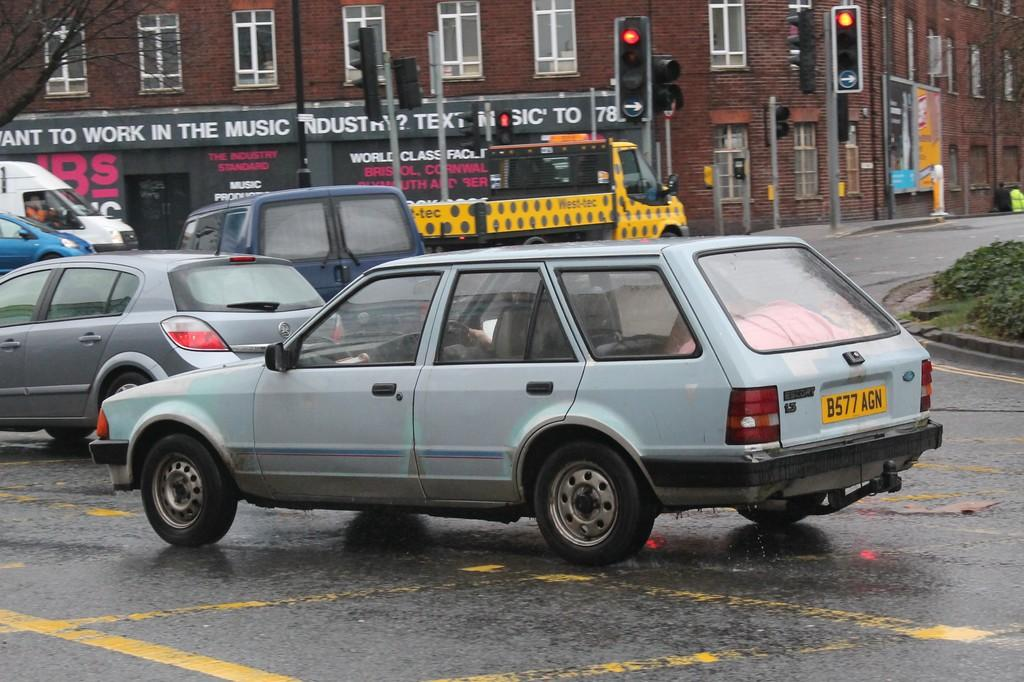Provide a one-sentence caption for the provided image. A compact light colored four door Ford Escort with a 1.3 liter engine. 